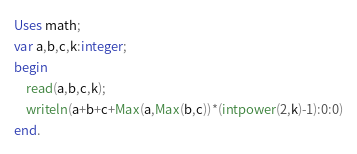Convert code to text. <code><loc_0><loc_0><loc_500><loc_500><_Pascal_>Uses math;
var a,b,c,k:integer;
begin
	read(a,b,c,k);
	writeln(a+b+c+Max(a,Max(b,c))*(intpower(2,k)-1):0:0)
end.</code> 